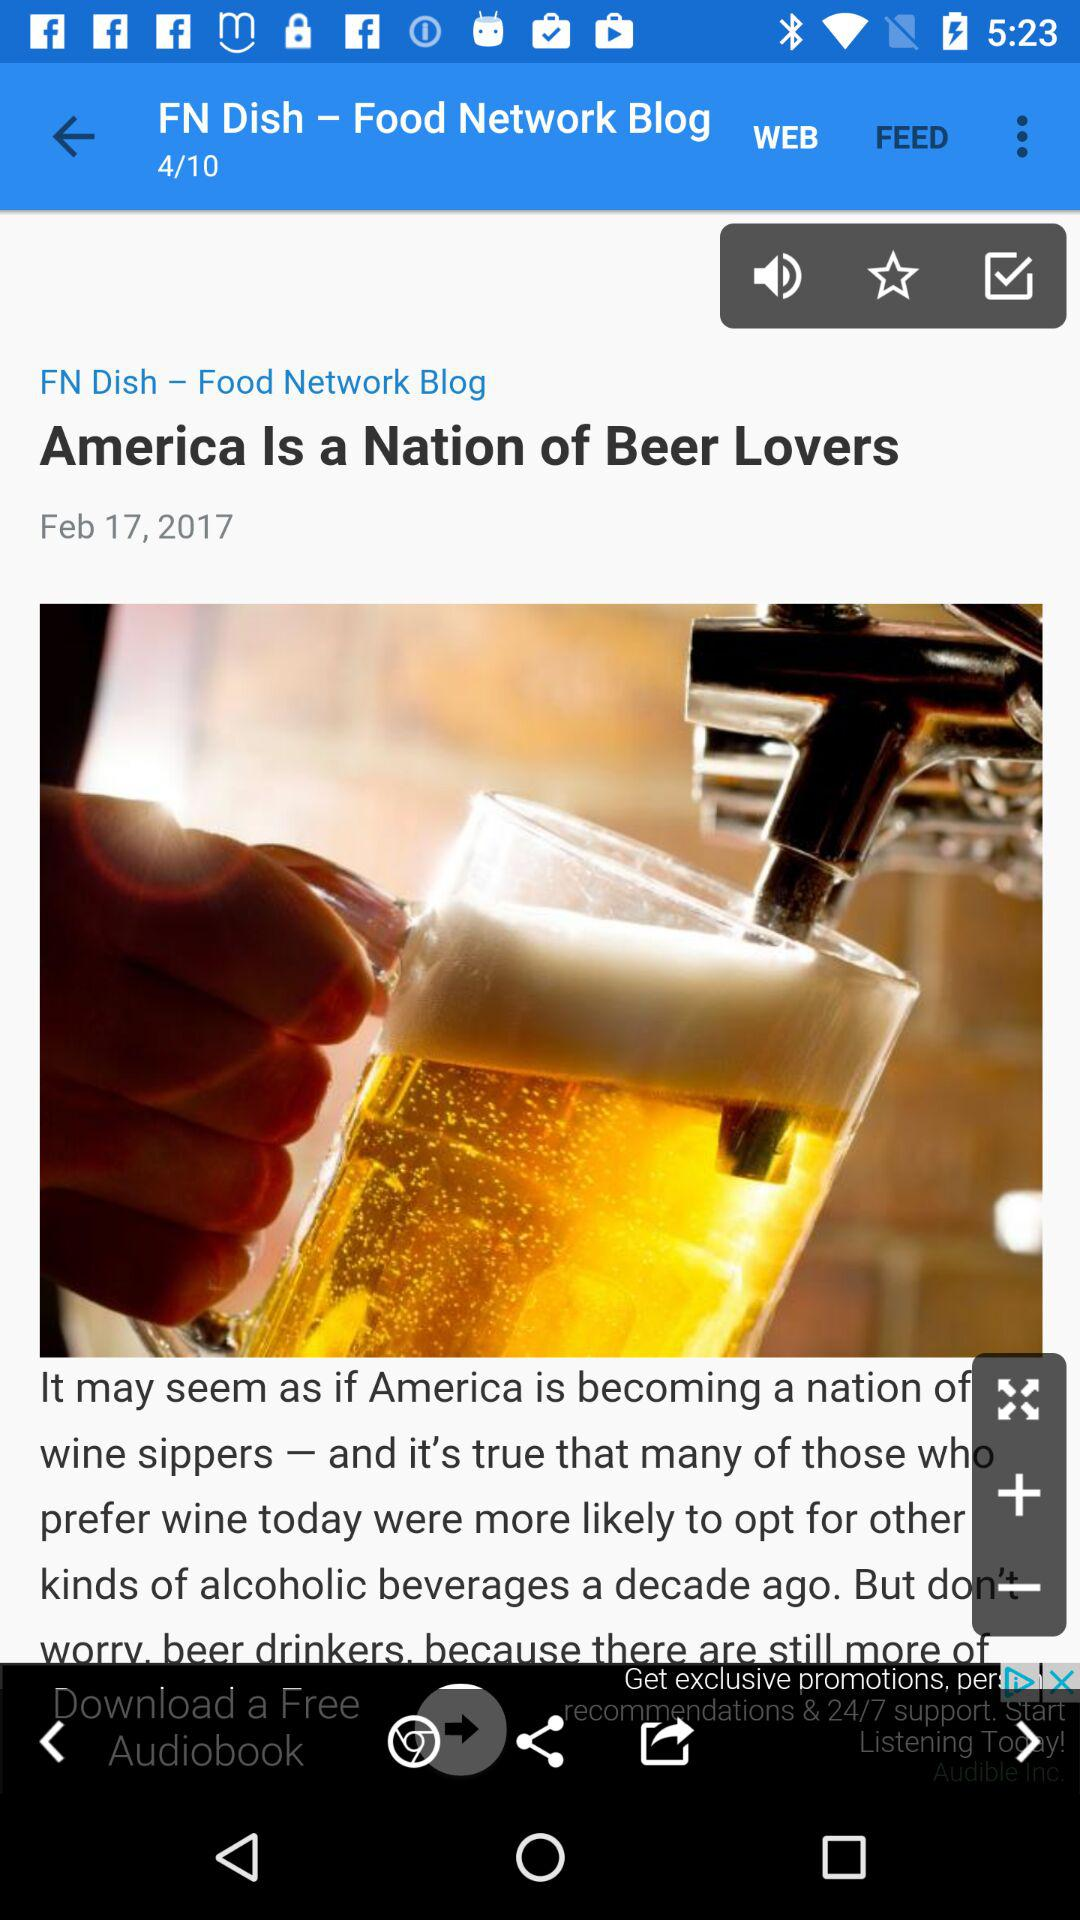How many blogs are there? There are 10 blogs. 